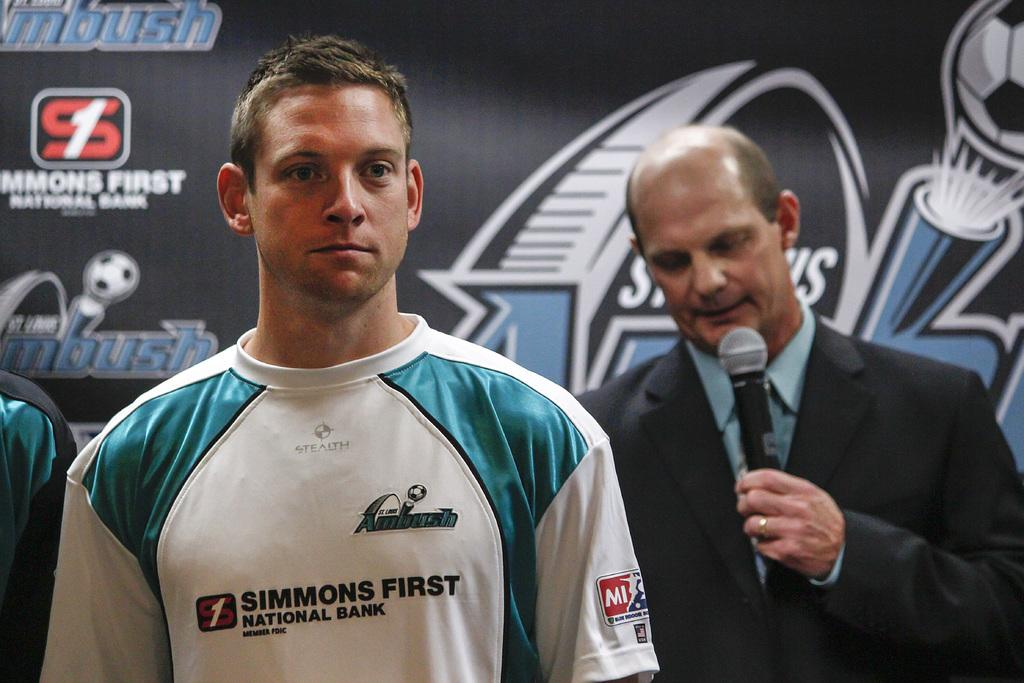<image>
Give a short and clear explanation of the subsequent image. Man wearing a shirt that says Simmons First in front of a man holding a mic. 